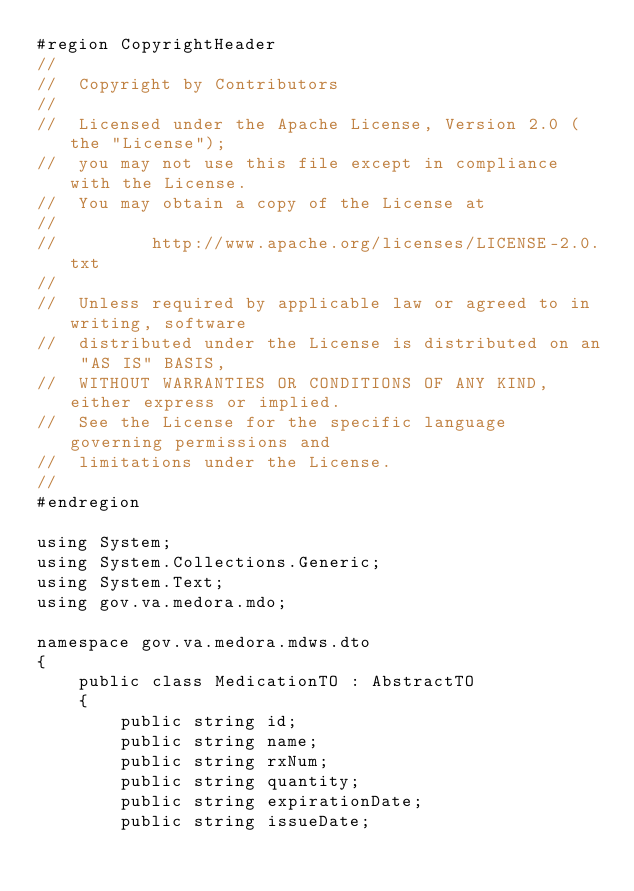Convert code to text. <code><loc_0><loc_0><loc_500><loc_500><_C#_>#region CopyrightHeader
//
//  Copyright by Contributors
//
//  Licensed under the Apache License, Version 2.0 (the "License");
//  you may not use this file except in compliance with the License.
//  You may obtain a copy of the License at
//
//         http://www.apache.org/licenses/LICENSE-2.0.txt
//
//  Unless required by applicable law or agreed to in writing, software
//  distributed under the License is distributed on an "AS IS" BASIS,
//  WITHOUT WARRANTIES OR CONDITIONS OF ANY KIND, either express or implied.
//  See the License for the specific language governing permissions and
//  limitations under the License.
//
#endregion

using System;
using System.Collections.Generic;
using System.Text;
using gov.va.medora.mdo;

namespace gov.va.medora.mdws.dto
{
    public class MedicationTO : AbstractTO
    {
        public string id;
        public string name;
        public string rxNum;
        public string quantity;
        public string expirationDate;
        public string issueDate;</code> 